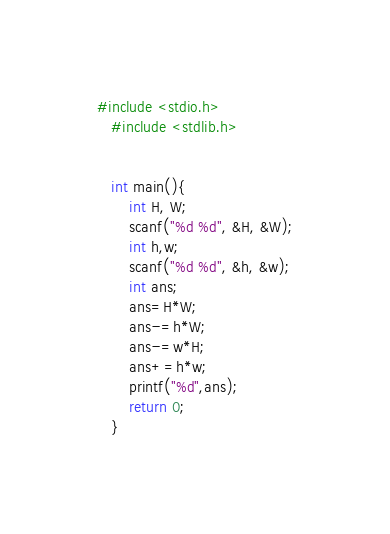<code> <loc_0><loc_0><loc_500><loc_500><_C_>#include <stdio.h>
   #include <stdlib.h>

    
   int main(){
       int H, W;
       scanf("%d %d", &H, &W);
       int h,w;
       scanf("%d %d", &h, &w);
       int ans;
       ans=H*W;
       ans-=h*W;
       ans-=w*H;
       ans+=h*w;
       printf("%d",ans);
       return 0;
   }</code> 